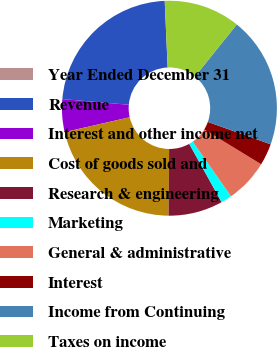Convert chart. <chart><loc_0><loc_0><loc_500><loc_500><pie_chart><fcel>Year Ended December 31<fcel>Revenue<fcel>Interest and other income net<fcel>Cost of goods sold and<fcel>Research & engineering<fcel>Marketing<fcel>General & administrative<fcel>Interest<fcel>Income from Continuing<fcel>Taxes on income<nl><fcel>0.0%<fcel>22.95%<fcel>4.92%<fcel>21.31%<fcel>8.2%<fcel>1.64%<fcel>6.56%<fcel>3.28%<fcel>19.67%<fcel>11.48%<nl></chart> 